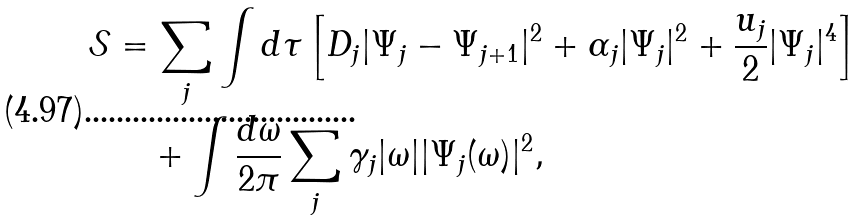Convert formula to latex. <formula><loc_0><loc_0><loc_500><loc_500>\mathcal { S } & = \sum _ { j } \int d \tau \left [ D _ { j } | \Psi _ { j } - \Psi _ { j + 1 } | ^ { 2 } + \alpha _ { j } | \Psi _ { j } | ^ { 2 } + \frac { u _ { j } } { 2 } | \Psi _ { j } | ^ { 4 } \right ] \\ & \quad + \int \frac { d \omega } { 2 \pi } \sum _ { j } \gamma _ { j } | \omega | | \Psi _ { j } ( \omega ) | ^ { 2 } ,</formula> 